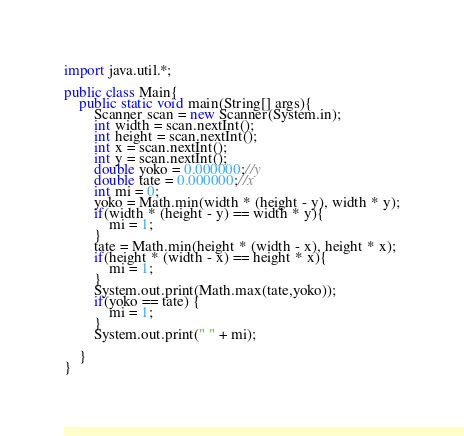<code> <loc_0><loc_0><loc_500><loc_500><_Java_>import java.util.*;
 
public class Main{
	public static void main(String[] args){
    	Scanner scan = new Scanner(System.in);
      	int width = scan.nextInt();	
      	int height = scan.nextInt();
      	int x = scan.nextInt();
      	int y = scan.nextInt();
      	double yoko = 0.000000;//y
      	double tate = 0.000000;//x
      	int mi = 0;
        yoko = Math.min(width * (height - y), width * y);
      	if(width * (height - y) == width * y){
        	mi = 1;
        }
      	tate = Math.min(height * (width - x), height * x);
      	if(height * (width - x) == height * x){
        	mi = 1;
        }
      	System.out.print(Math.max(tate,yoko));
      	if(yoko == tate) {
        	mi = 1;
        }
      	System.out.print(" " + mi);
    
    }
}</code> 